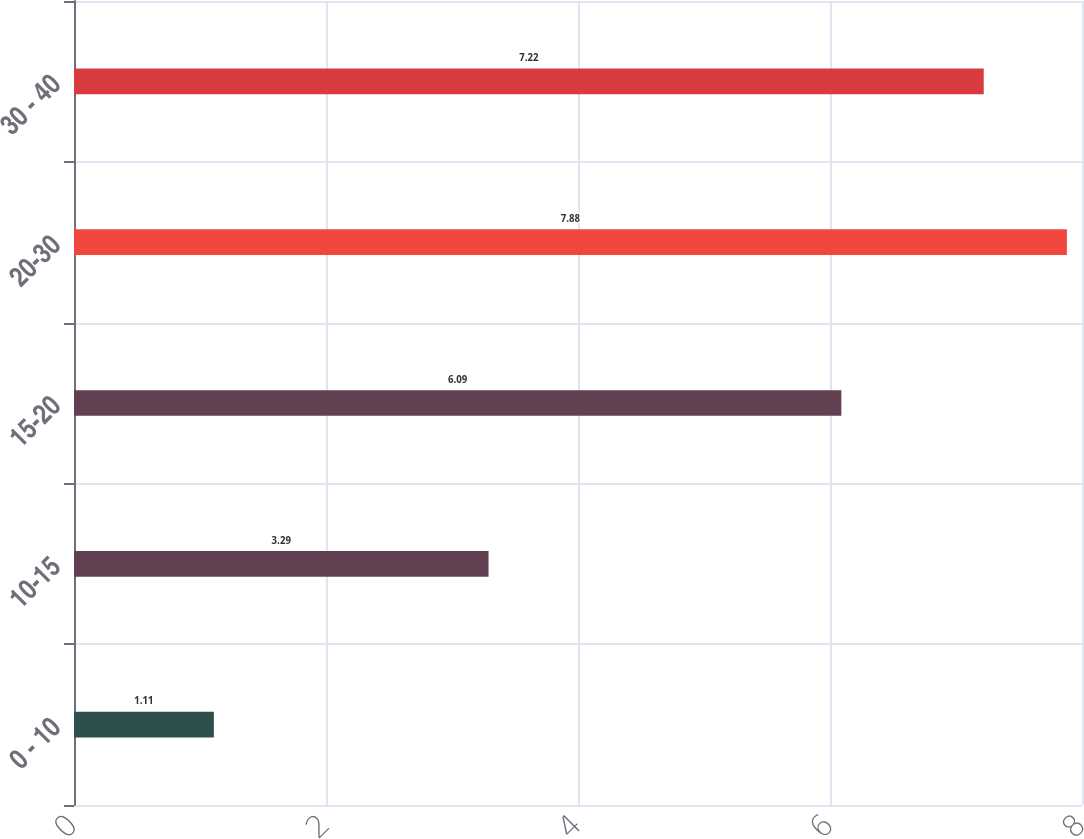Convert chart. <chart><loc_0><loc_0><loc_500><loc_500><bar_chart><fcel>0 - 10<fcel>10-15<fcel>15-20<fcel>20-30<fcel>30 - 40<nl><fcel>1.11<fcel>3.29<fcel>6.09<fcel>7.88<fcel>7.22<nl></chart> 